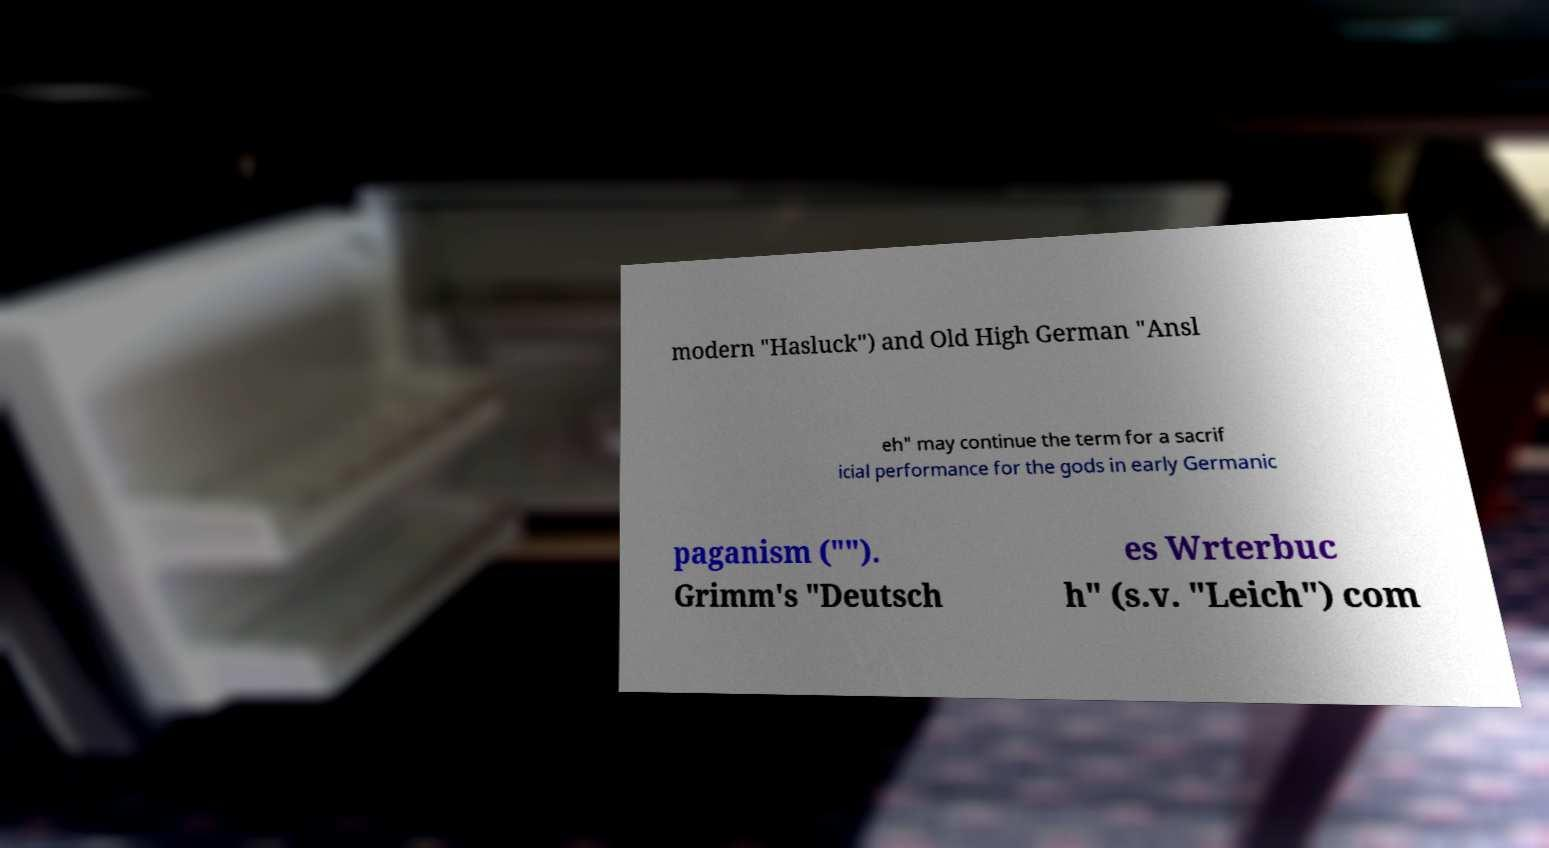Please read and relay the text visible in this image. What does it say? modern "Hasluck") and Old High German "Ansl eh" may continue the term for a sacrif icial performance for the gods in early Germanic paganism (""). Grimm's "Deutsch es Wrterbuc h" (s.v. "Leich") com 